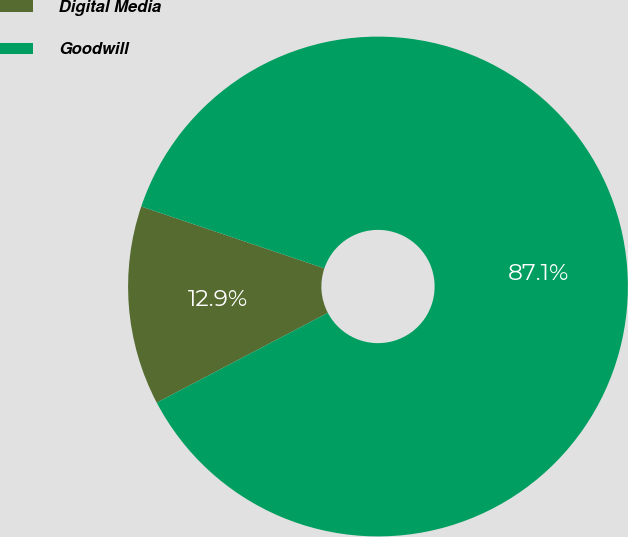Convert chart to OTSL. <chart><loc_0><loc_0><loc_500><loc_500><pie_chart><fcel>Digital Media<fcel>Goodwill<nl><fcel>12.88%<fcel>87.12%<nl></chart> 